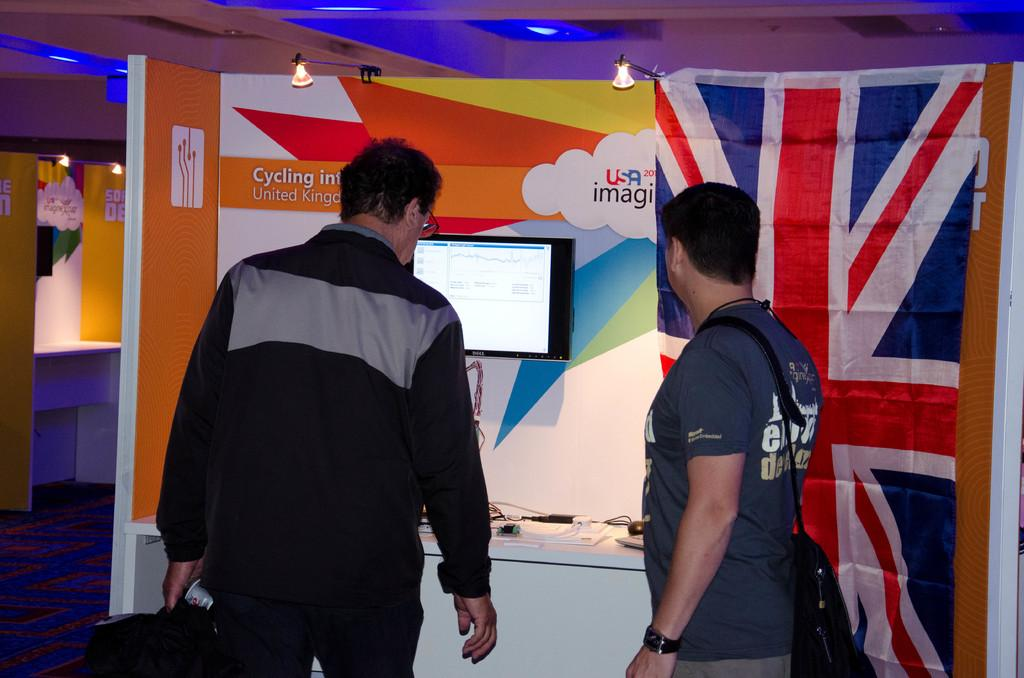What can be seen in the image in terms of human presence? There are people standing in the image. What is located on a platform in the image? There are objects on a platform in the image. What type of electronic device is visible in the image? A television is visible in the image. What type of signage is present in the image? Hoardings are present in the image. What type of symbolic objects are visible in the image? Flags are visible in the image. What type of surface is visible in the image? The floor is visible in the image. What type of lighting is present at the top of the image? There are lights at the top of the image. What type of tin can be seen being raked by a person in the image? There is no tin or rake present in the image. How does the rubbing of the flags create a unique texture in the image? The flags are not being rubbed in the image; they are simply visible. 